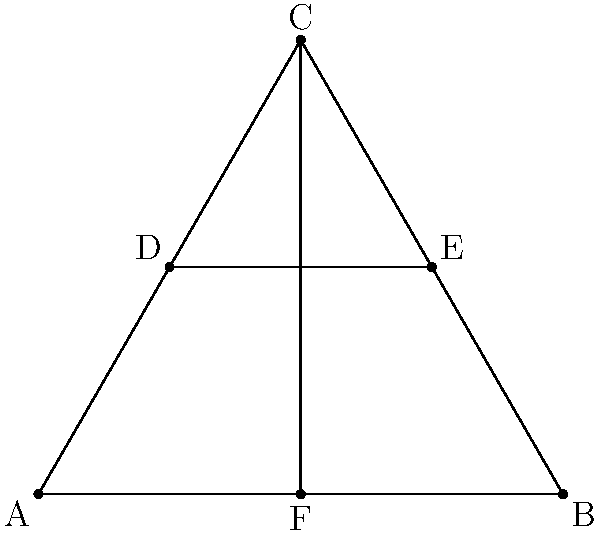In designing an efficient layout for a large-scale solar farm, you're considering a triangular arrangement of panels. The diagram shows an equilateral triangle ABC with side length 5 units. Points D and E are midpoints of AC and BC respectively, and F is the midpoint of AB. If each unit represents 100 meters, what is the total area (in square kilometers) that can be covered by solar panels if they are installed in the shaded region CDEF? To solve this problem, we'll follow these steps:

1) First, we need to calculate the area of the equilateral triangle ABC.
   The area of an equilateral triangle is given by the formula: 
   $$A = \frac{\sqrt{3}}{4}a^2$$
   where $a$ is the side length.

2) With $a = 5$ units, the area of ABC is:
   $$A_{ABC} = \frac{\sqrt{3}}{4} \cdot 5^2 = \frac{25\sqrt{3}}{4} \approx 10.825$$ square units

3) The shaded area CDEF is composed of two parts:
   - The upper triangle CDE
   - The lower trapezoid DEFF'

4) Triangle CDE is similar to ABC, with its side length being half of ABC.
   Its area is therefore $\frac{1}{4}$ of ABC's area:
   $$A_{CDE} = \frac{1}{4} \cdot \frac{25\sqrt{3}}{4} = \frac{25\sqrt{3}}{16} \approx 2.706$$ square units

5) The trapezoid DEFF' has a height of $\frac{\sqrt{3}}{4}a = \frac{5\sqrt{3}}{4}$ and bases of length $\frac{5}{4}$ and $\frac{5}{2}$.
   Its area is:
   $$A_{DEFF'} = \frac{1}{2}(\frac{5}{4} + \frac{5}{2}) \cdot \frac{5\sqrt{3}}{4} = \frac{75\sqrt{3}}{32} \approx 4.059$$ square units

6) The total shaded area is:
   $$A_{CDEF} = A_{CDE} + A_{DEFF'} = \frac{25\sqrt{3}}{16} + \frac{75\sqrt{3}}{32} = \frac{125\sqrt{3}}{32} \approx 6.765$$ square units

7) Each unit represents 100 meters, so we need to convert to square kilometers:
   $$6.765 \cdot (0.1)^2 = 0.06765$$ square kilometers

Therefore, the solar panels can cover approximately 0.06765 square kilometers.
Answer: 0.06765 km² 